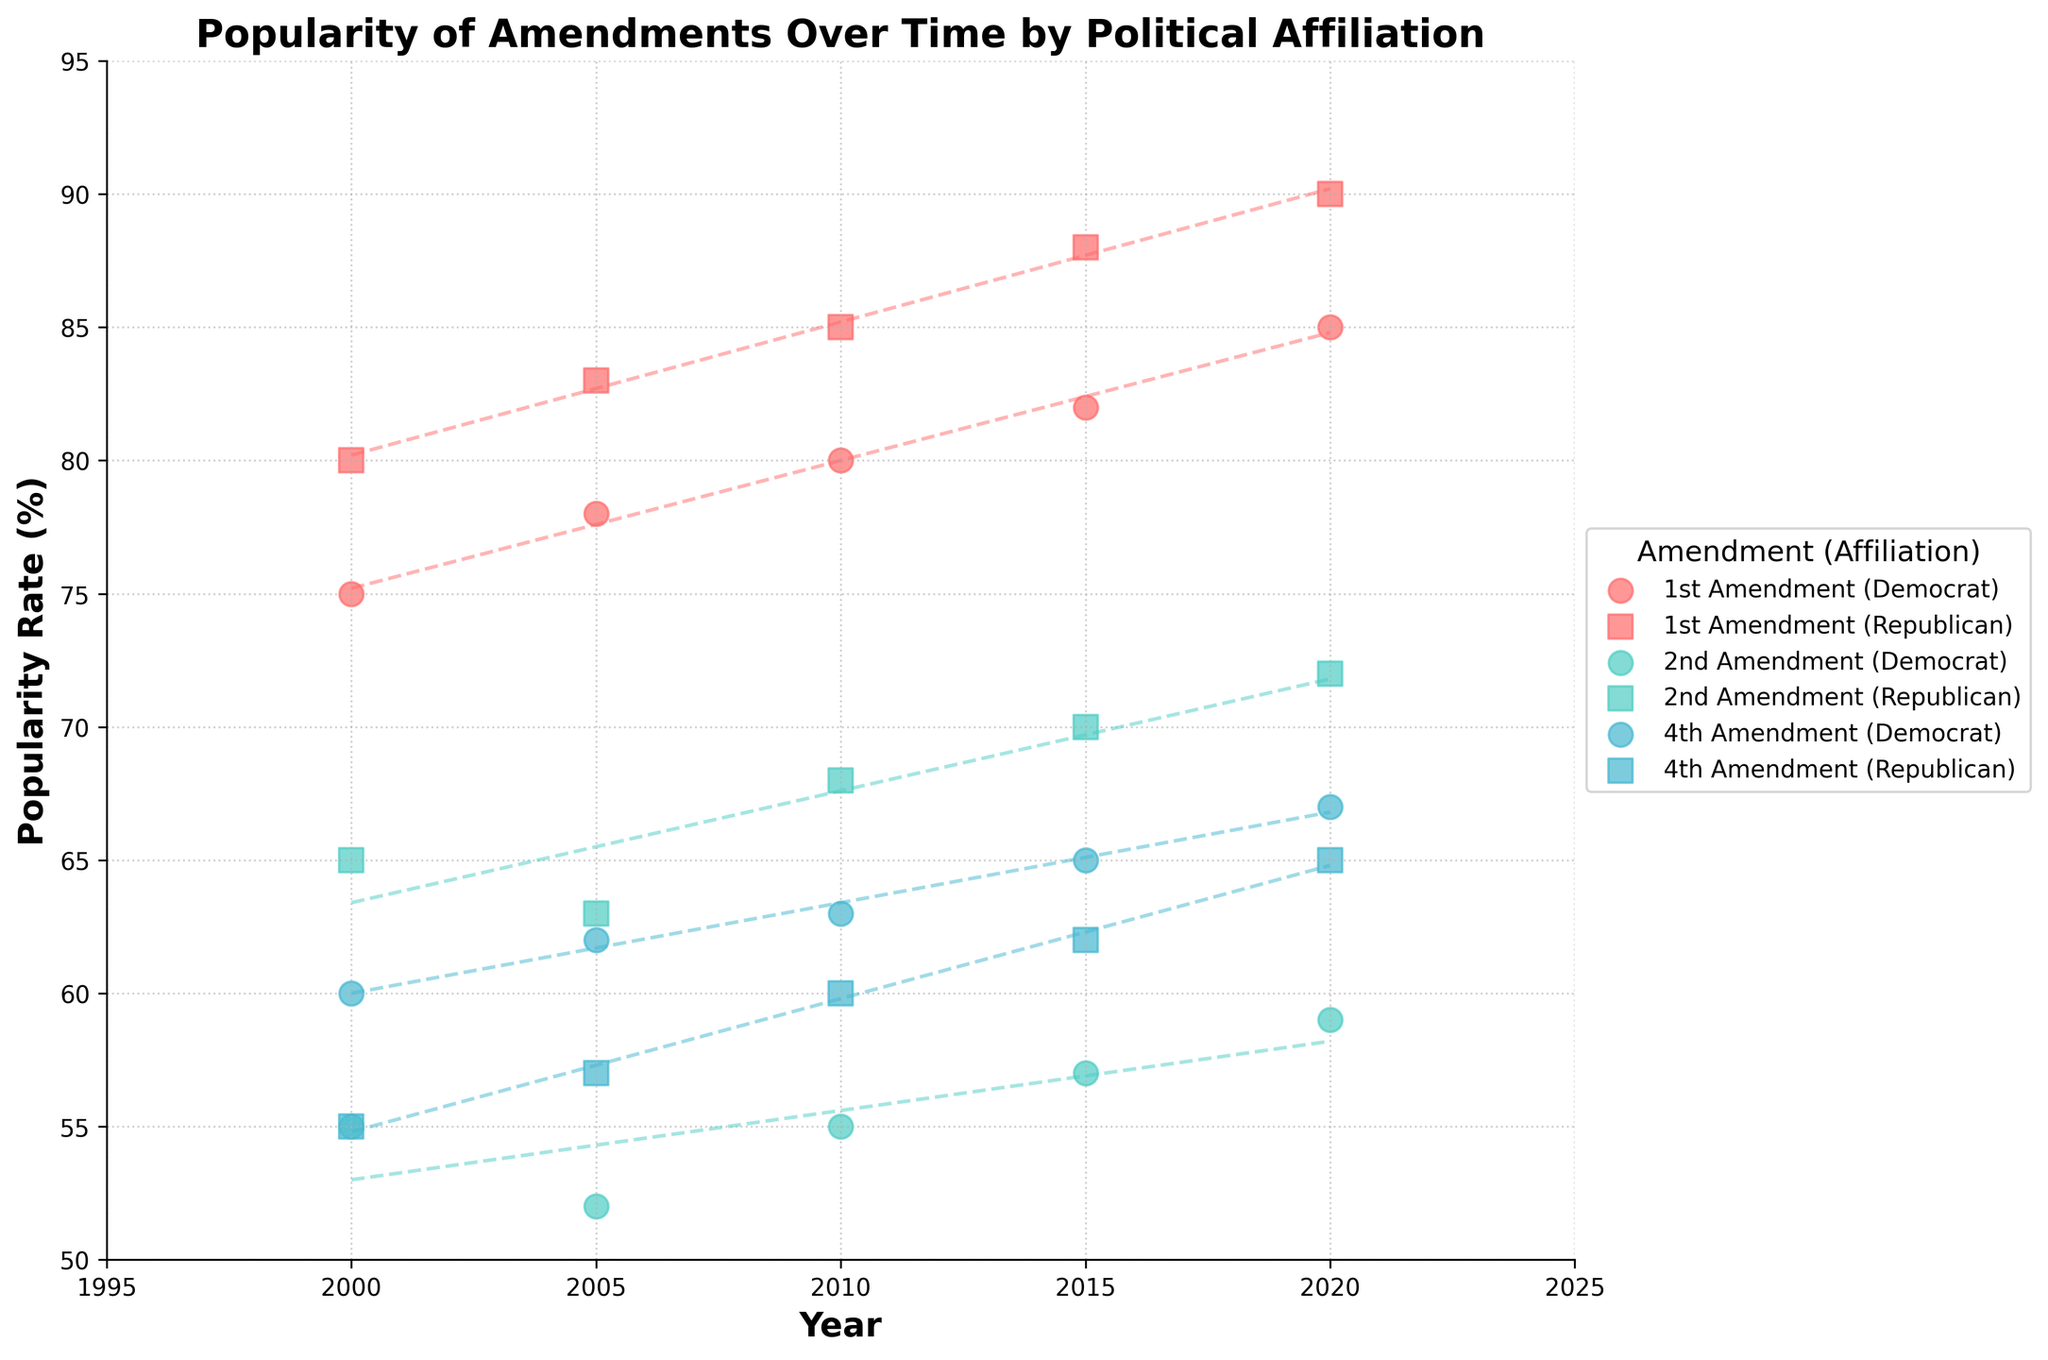What is the title of the plot? The title is located at the top center of the plot. It reads "Popularity of Amendments Over Time by Political Affiliation."
Answer: Popularity of Amendments Over Time by Political Affiliation How many data points are plotted for the 1st Amendment for Democrats? By locating the 1st Amendment data for Democrats in the figure and counting the markers along the Democratic trend, we find five data points: 2000, 2005, 2010, 2015, and 2020.
Answer: Five Which political affiliation shows a higher popularity rate for the 2nd Amendment in 2020? By looking at the data points for the 2nd Amendment in 2020, we compare the positions of the markers for Democrats and Republicans. The Republican rate (72) is higher than the Democrat rate (59).
Answer: Republicans Has the popularity rate of the 1st Amendment increased or decreased over time for Republicans? Observing the trend line for Republicans affiliated with the 1st Amendment, we see an upward (increasing) slope from 2000 to 2020.
Answer: Increased What is the average popularity rate of the 4th Amendment over time for Democrats? Locate the points for the 4th Amendment for Democrats: 2000 (60), 2005 (62), 2010 (63), 2015 (65), 2020 (67). The average is calculated as (60 + 62 + 63 + 65 + 67) / 5 = 63.4.
Answer: 63.4 Which amendment has shown the most consistent trend over time, regardless of political affiliation? By observing the stability and smoothness of the trend lines across both political affiliations, the 1st Amendment has minimal fluctuations and clear upward trends for both affiliations.
Answer: 1st Amendment What is the difference in popularity rate for the 4th Amendment between 2000 and 2020 among Republicans? The rates are 55 (2000) and 65 (2020). The difference is 65 - 55 = 10.
Answer: 10 Which amendment had the largest increase in popularity for Democrats from 2000 to 2020? Compare the differences for each amendment: 1st (85 - 75 = 10), 2nd (59 - 55 = 4), 4th (67 - 60 = 7). The 1st Amendment had a 10-point increase, the largest among the three.
Answer: 1st Amendment Do both political affiliations show an increasing trend in the popularity of the 2nd Amendment? The trend lines for both Democrats (slightly increasing) and Republicans (more steeply increasing) show an upward trajectory from 2000 to 2020.
Answer: Yes Is there any amendment where both political affiliations had almost the same popularity rate in 2000? Examining the data points for 2000 for both affiliations: 1st (75, 80), 2nd (55, 65), 4th (60, 55). The 4th Amendment had almost the same rates of 60 (Democrats) and 55 (Republicans).
Answer: 4th Amendment 